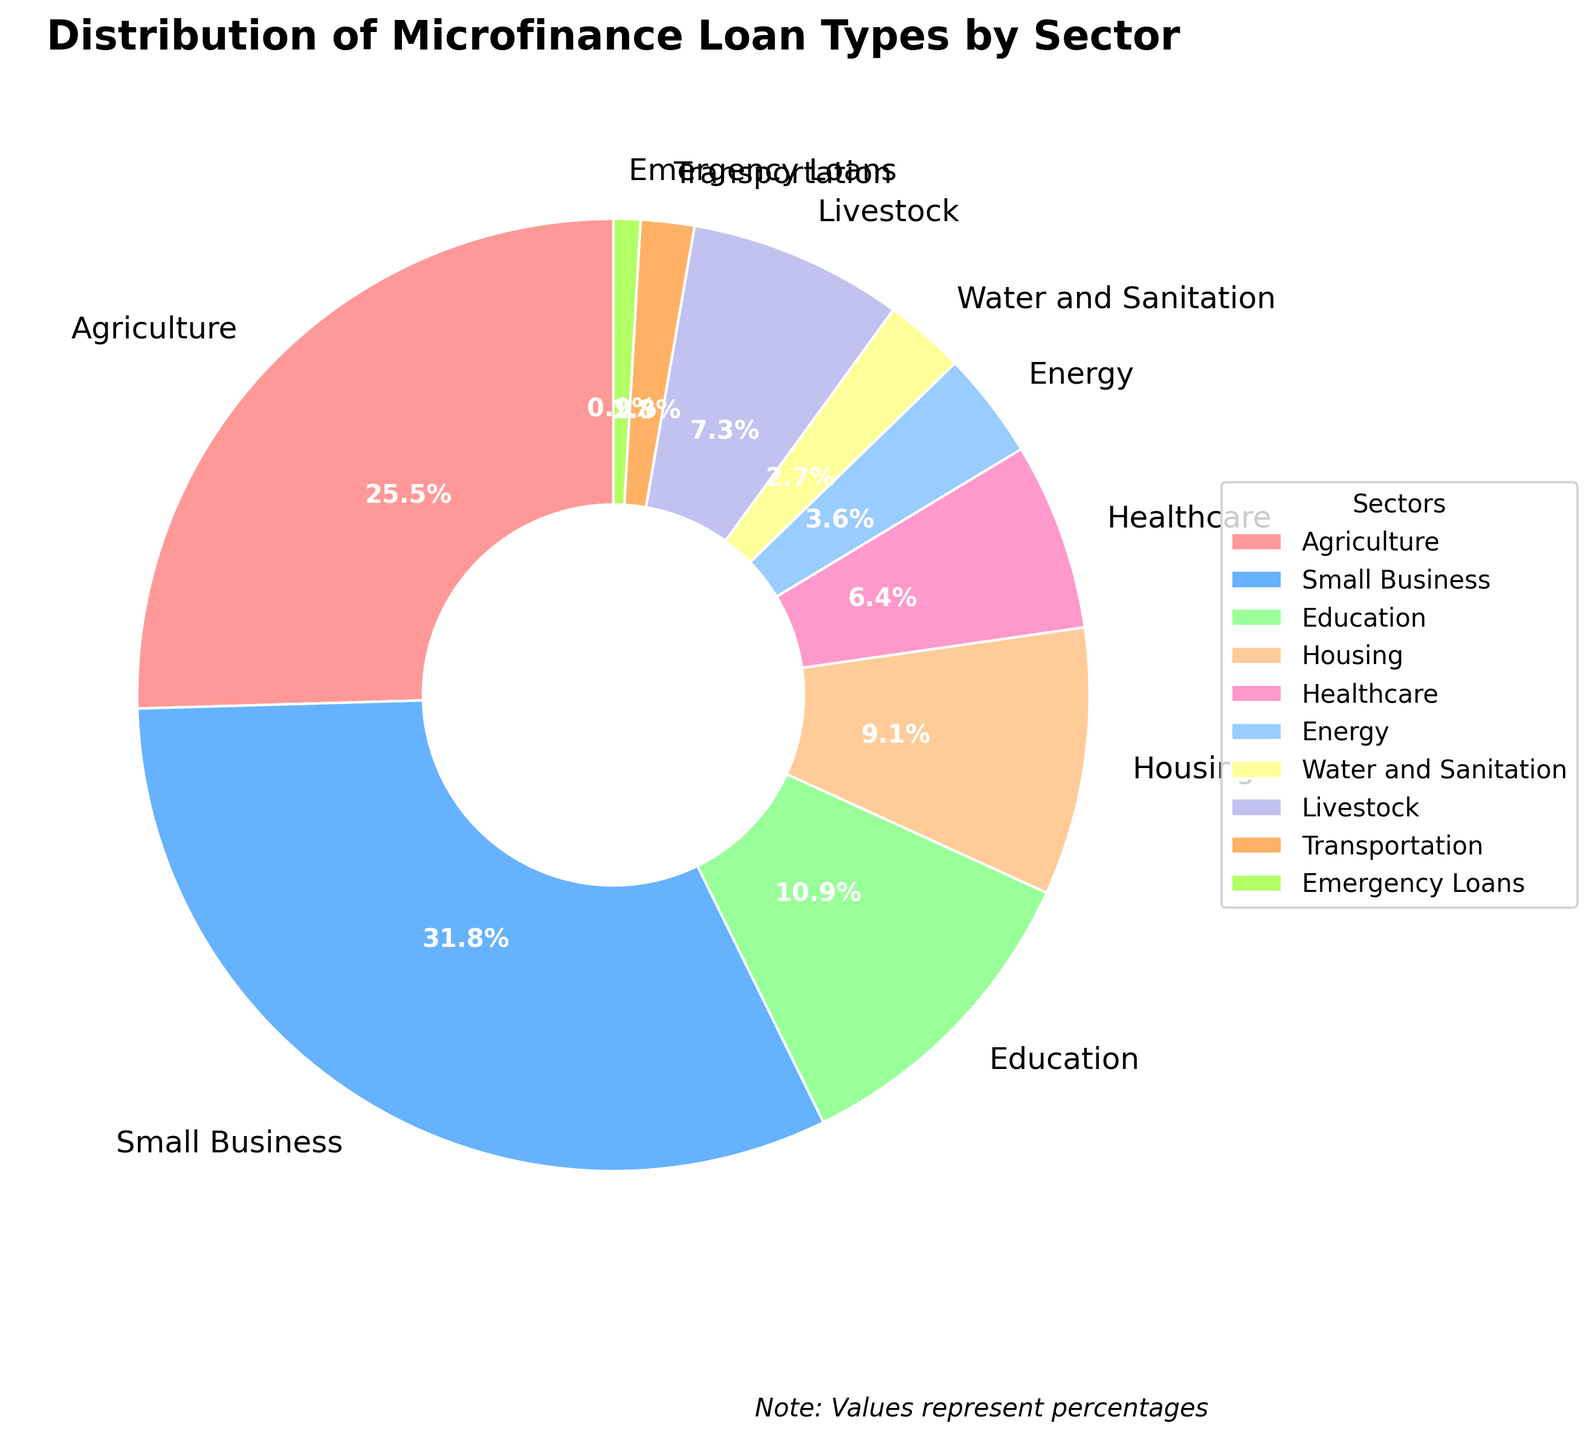Which sector received the highest percentage of loans? The highest percentage in the pie chart is 35%, which corresponds to the "Small Business" sector.
Answer: Small Business What is the combined percentage of loans given to Agriculture and Livestock? Agriculture has 28% and Livestock has 8%. Their combined percentage is 28 + 8 = 36%.
Answer: 36% Which sector received the lowest percentage of loans? The smallest percentage in the pie chart is 1%, which corresponds to the "Emergency Loans" sector.
Answer: Emergency Loans How much greater is the percentage of loans given to Small Business compared to Education? Small Business has 35% and Education has 12%. The difference is 35 - 12 = 23%.
Answer: 23% What color represents the Healthcare sector in the pie chart? The pie chart's legend shows that Healthcare is represented by the light pink color closest to #FF99CC.
Answer: Light Pink What is the sum of percentages for Housing, Healthcare, and Energy sectors? Housing has 10%, Healthcare has 7%, and Energy has 4%. Their combined percentage is 10 + 7 + 4 = 21%.
Answer: 21% Circle the sectors that make up exactly half (50%) of the total loans. Small Business has 35% and Agriculture has 28%. Together, they make 35 + 28 = 63%, which exceeds 50%. Instead, Small Business and Livestock (35% + 8% = 43%) fall short. The closest combination is Small Business and Education (35% + 12%) plus a small part from others like Healthcare. Since it's complex to match exact 50%, none fully.
Answer: None exact, mostly Small Business and Education Which sectors combined have a larger percentage than the Small Business sector? Combined means adding up the percentages of different sectors. Agriculture (28%), Education (12%), and Housing (10%) sums up as 28 + 12 + 10 = 50%, which is more than 35%.
Answer: Agriculture, Education, Housing What percentage of loans are allocated to sectors other than Small Business and Agriculture? Small Business has 35% and Agriculture has 28%. The remaining percentage is 100 - (35 + 28) = 100 - 63 = 37%.
Answer: 37% Compare the combined percentages of loans given to Healthcare and Energy with that given to Housing. Is it more or less? Healthcare is 7% and Energy is 4%, combined they are 7 + 4 = 11%. Housing is 10%. So, Healthcare and Energy combined (11%) provide 1% more than Housing (10%).
Answer: More 